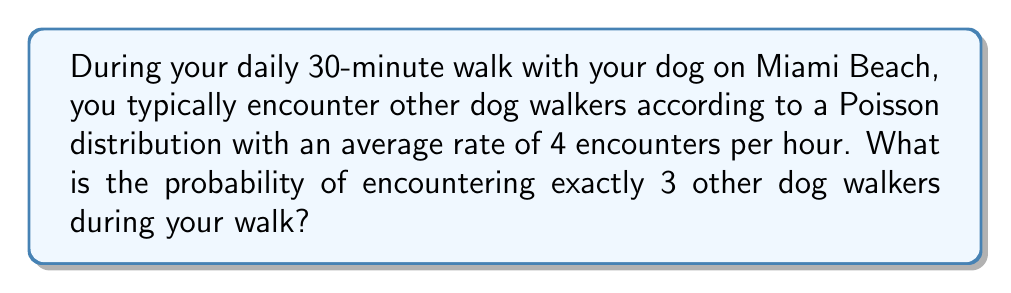Teach me how to tackle this problem. To solve this problem, we'll use the Poisson distribution formula:

$$P(X = k) = \frac{e^{-\lambda} \lambda^k}{k!}$$

Where:
- $X$ is the number of events (encounters with other dog walkers)
- $k$ is the specific number of events we're interested in (3 in this case)
- $\lambda$ is the average rate of events per unit time

Steps:
1. Calculate $\lambda$ for a 30-minute walk:
   Given rate = 4 encounters/hour
   $\lambda = 4 \times \frac{30}{60} = 2$ encounters per 30-minute walk

2. Apply the Poisson distribution formula:
   $P(X = 3) = \frac{e^{-2} 2^3}{3!}$

3. Calculate:
   $P(X = 3) = \frac{e^{-2} \times 8}{6}$
   
4. Evaluate:
   $P(X = 3) \approx 0.1804$

Therefore, the probability of encountering exactly 3 other dog walkers during your 30-minute walk is approximately 0.1804 or 18.04%.
Answer: $0.1804$ or $18.04\%$ 